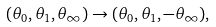<formula> <loc_0><loc_0><loc_500><loc_500>( \theta _ { 0 } , \theta _ { 1 } , \theta _ { \infty } ) \to ( \theta _ { 0 } , \theta _ { 1 } , - \theta _ { \infty } ) ,</formula> 